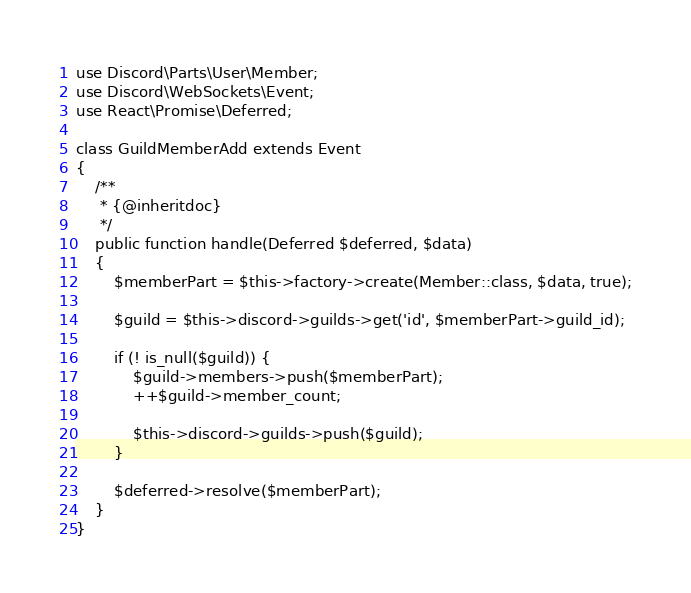Convert code to text. <code><loc_0><loc_0><loc_500><loc_500><_PHP_>use Discord\Parts\User\Member;
use Discord\WebSockets\Event;
use React\Promise\Deferred;

class GuildMemberAdd extends Event
{
    /**
     * {@inheritdoc}
     */
    public function handle(Deferred $deferred, $data)
    {
        $memberPart = $this->factory->create(Member::class, $data, true);

        $guild = $this->discord->guilds->get('id', $memberPart->guild_id);

        if (! is_null($guild)) {
            $guild->members->push($memberPart);
            ++$guild->member_count;

            $this->discord->guilds->push($guild);
        }

        $deferred->resolve($memberPart);
    }
}
</code> 